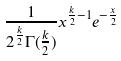<formula> <loc_0><loc_0><loc_500><loc_500>\frac { 1 } { 2 ^ { \frac { k } { 2 } } \Gamma ( \frac { k } { 2 } ) } x ^ { \frac { k } { 2 } - 1 } e ^ { - \frac { x } { 2 } }</formula> 